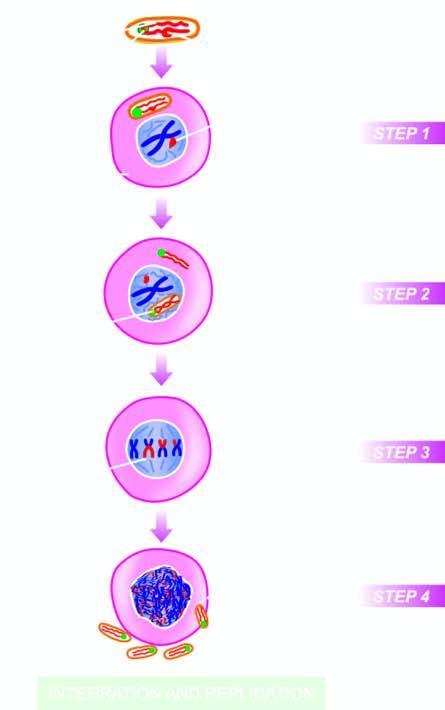what are released into the cytosol?
Answer the question using a single word or phrase. Viral rna genome 